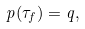Convert formula to latex. <formula><loc_0><loc_0><loc_500><loc_500>p ( \tau _ { f } ) = q ,</formula> 